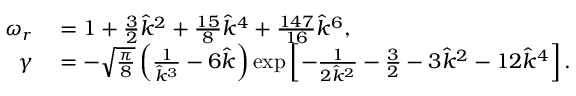<formula> <loc_0><loc_0><loc_500><loc_500>\begin{array} { r l } { \omega _ { r } } & = 1 + \frac { 3 } { 2 } \hat { k } ^ { 2 } + \frac { 1 5 } { 8 } \hat { k } ^ { 4 } + \frac { 1 4 7 } { 1 6 } \hat { k } ^ { 6 } , } \\ { \gamma } & = - \sqrt { \frac { \pi } { 8 } } \left ( \frac { 1 } { \hat { k } ^ { 3 } } - 6 \hat { k } \right ) \exp \left [ - \frac { 1 } { 2 \hat { k } ^ { 2 } } - \frac { 3 } { 2 } - 3 \hat { k } ^ { 2 } - 1 2 \hat { k } ^ { 4 } \right ] . } \end{array}</formula> 